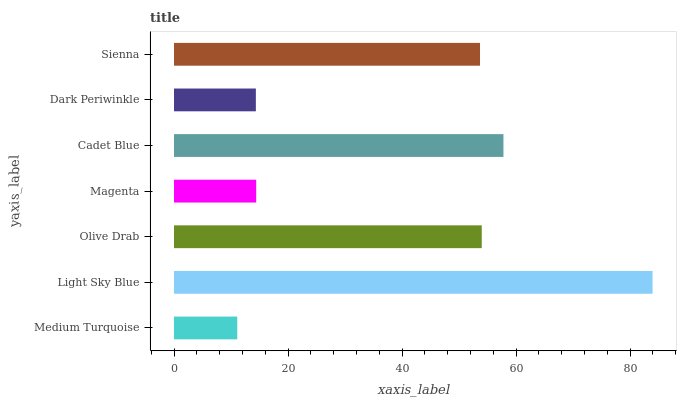Is Medium Turquoise the minimum?
Answer yes or no. Yes. Is Light Sky Blue the maximum?
Answer yes or no. Yes. Is Olive Drab the minimum?
Answer yes or no. No. Is Olive Drab the maximum?
Answer yes or no. No. Is Light Sky Blue greater than Olive Drab?
Answer yes or no. Yes. Is Olive Drab less than Light Sky Blue?
Answer yes or no. Yes. Is Olive Drab greater than Light Sky Blue?
Answer yes or no. No. Is Light Sky Blue less than Olive Drab?
Answer yes or no. No. Is Sienna the high median?
Answer yes or no. Yes. Is Sienna the low median?
Answer yes or no. Yes. Is Medium Turquoise the high median?
Answer yes or no. No. Is Light Sky Blue the low median?
Answer yes or no. No. 